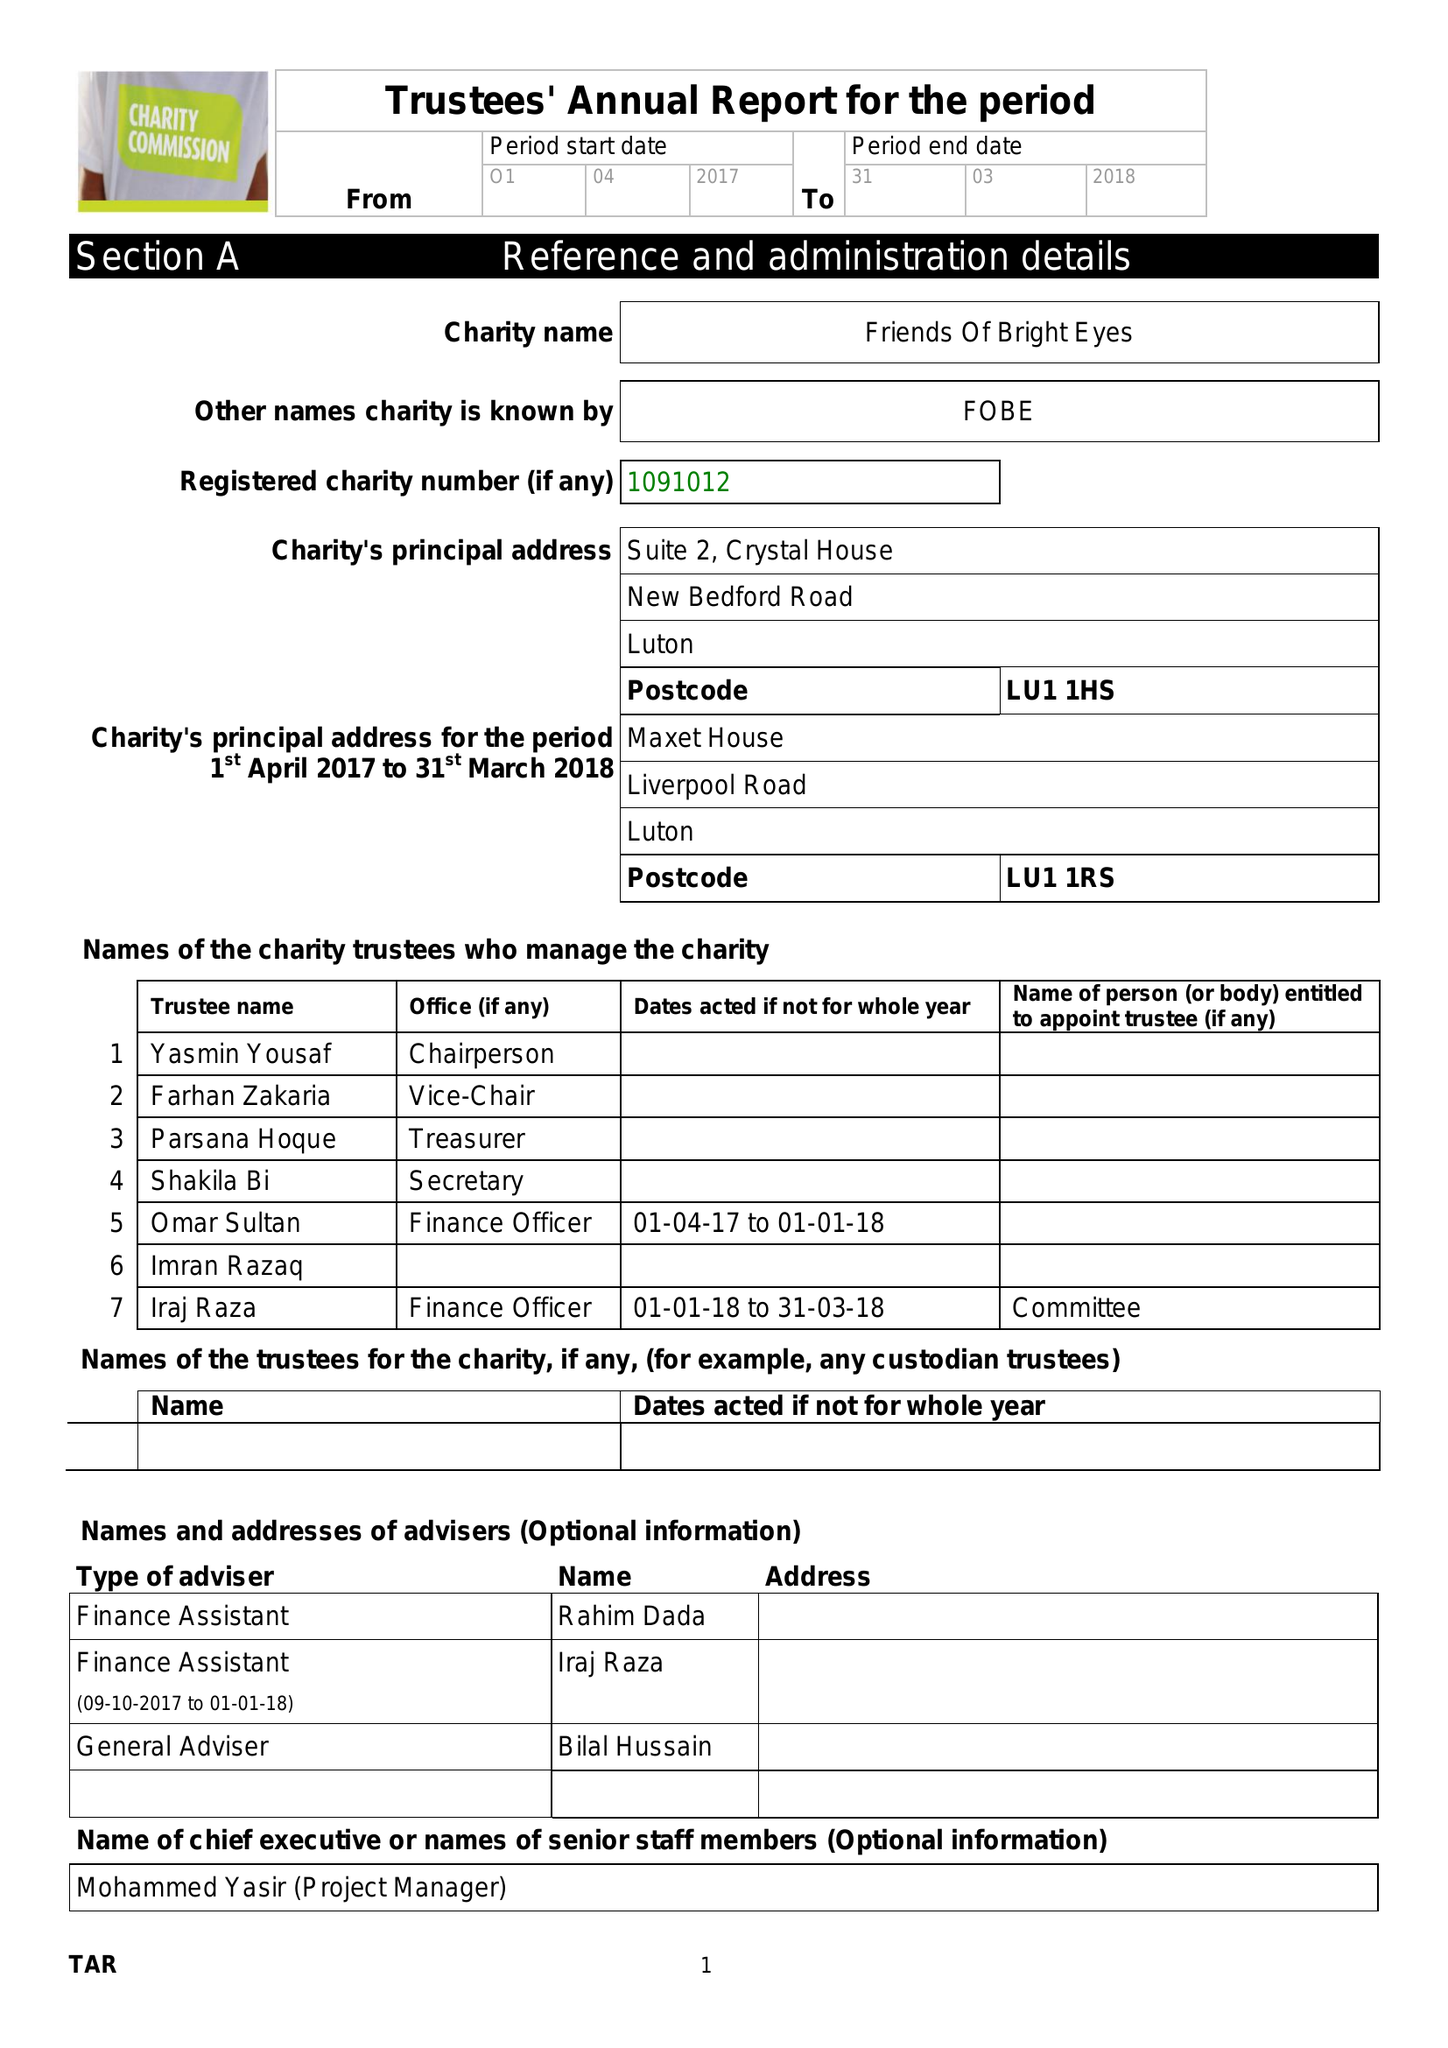What is the value for the charity_number?
Answer the question using a single word or phrase. 1091012 